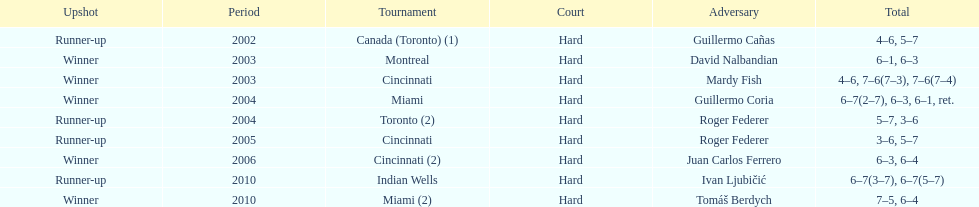How many consecutive years was there a hard surface at the championship? 9. 